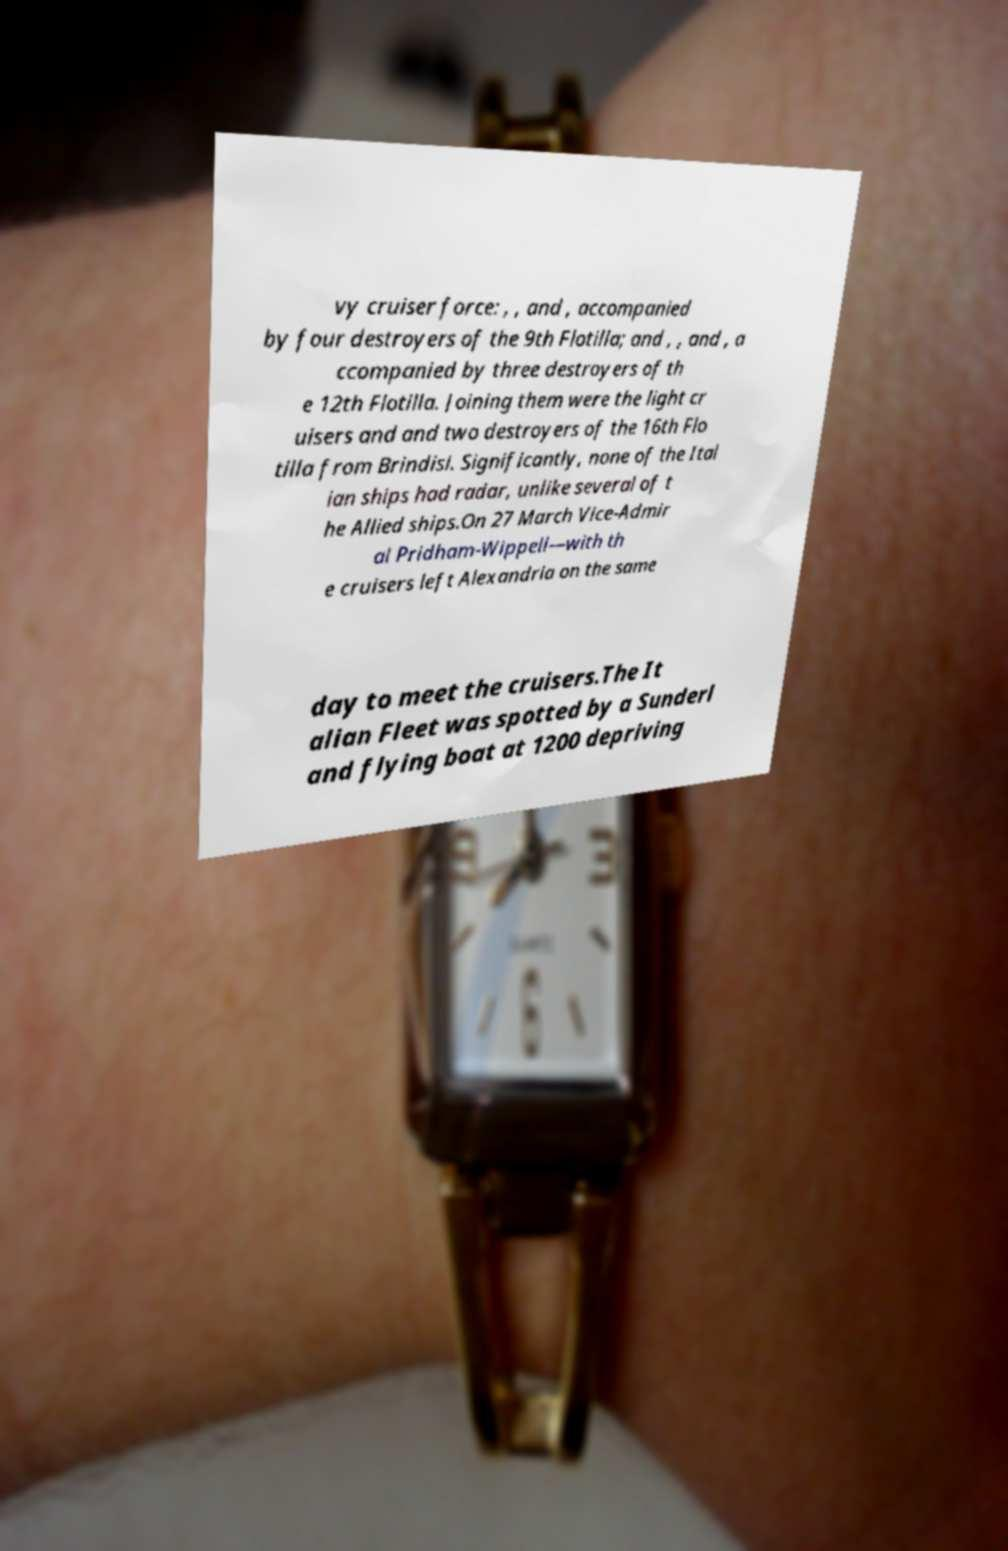What messages or text are displayed in this image? I need them in a readable, typed format. vy cruiser force: , , and , accompanied by four destroyers of the 9th Flotilla; and , , and , a ccompanied by three destroyers of th e 12th Flotilla. Joining them were the light cr uisers and and two destroyers of the 16th Flo tilla from Brindisi. Significantly, none of the Ital ian ships had radar, unlike several of t he Allied ships.On 27 March Vice-Admir al Pridham-Wippell—with th e cruisers left Alexandria on the same day to meet the cruisers.The It alian Fleet was spotted by a Sunderl and flying boat at 1200 depriving 